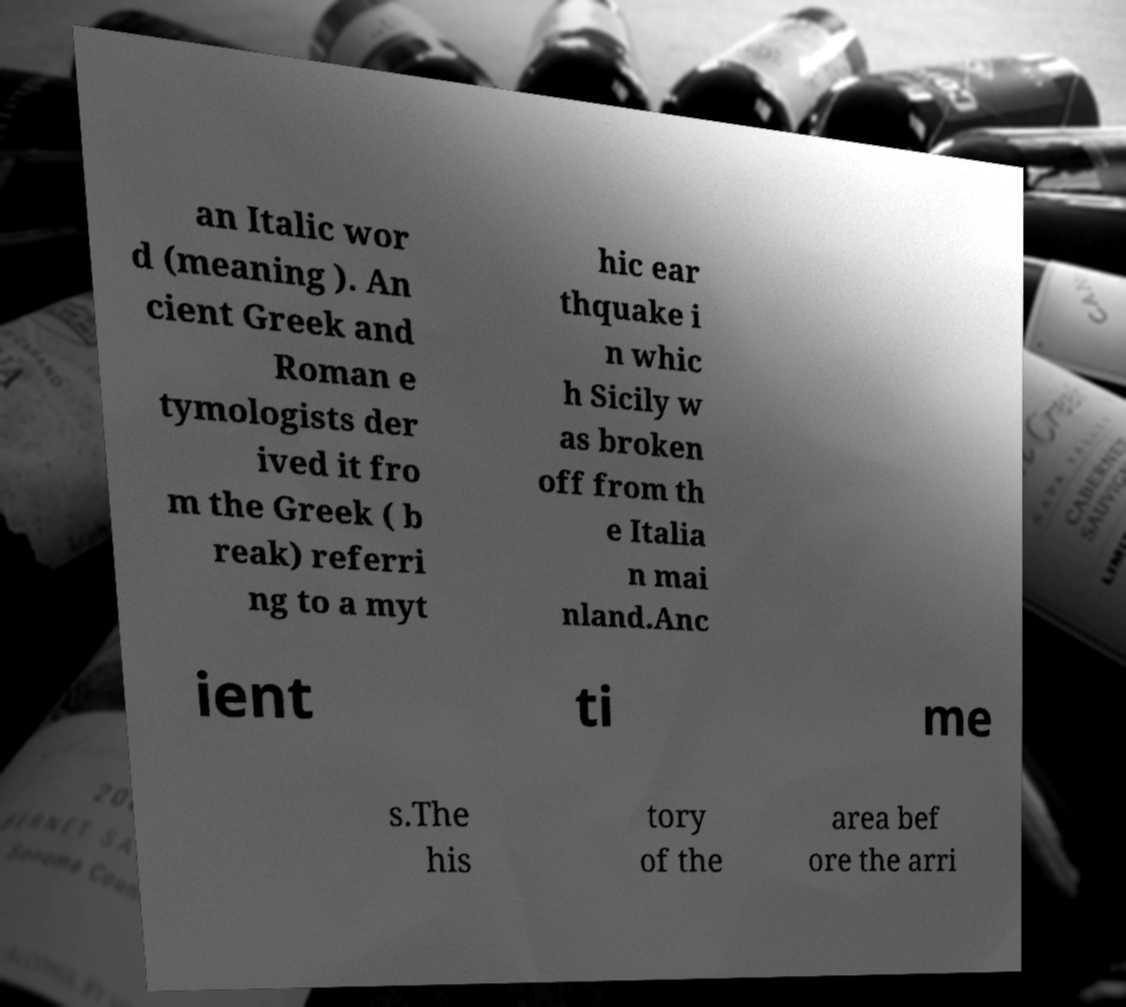For documentation purposes, I need the text within this image transcribed. Could you provide that? an Italic wor d (meaning ). An cient Greek and Roman e tymologists der ived it fro m the Greek ( b reak) referri ng to a myt hic ear thquake i n whic h Sicily w as broken off from th e Italia n mai nland.Anc ient ti me s.The his tory of the area bef ore the arri 